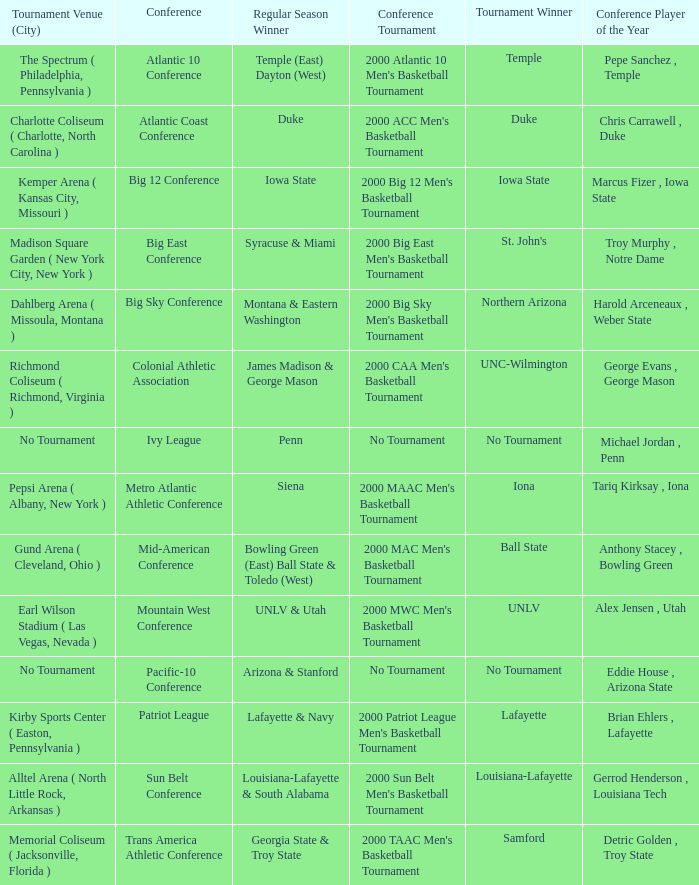How many players of the year are there in the Mountain West Conference? 1.0. 